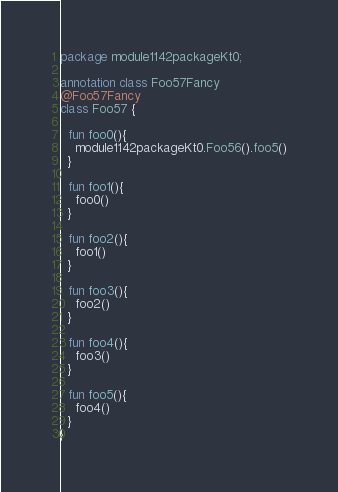<code> <loc_0><loc_0><loc_500><loc_500><_Kotlin_>package module1142packageKt0;

annotation class Foo57Fancy
@Foo57Fancy
class Foo57 {

  fun foo0(){
    module1142packageKt0.Foo56().foo5()
  }

  fun foo1(){
    foo0()
  }

  fun foo2(){
    foo1()
  }

  fun foo3(){
    foo2()
  }

  fun foo4(){
    foo3()
  }

  fun foo5(){
    foo4()
  }
}</code> 